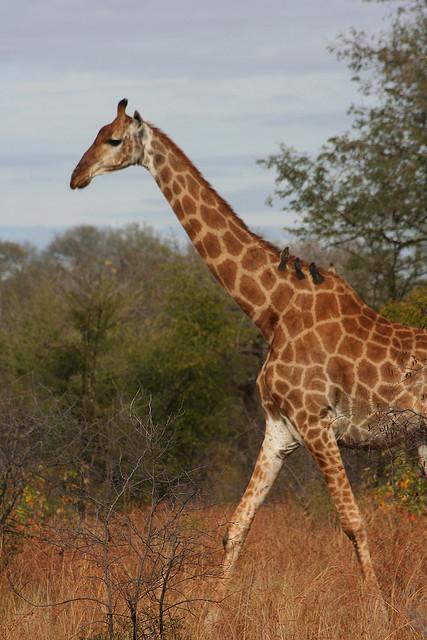How many giraffes can be seen?
Give a very brief answer. 1. 